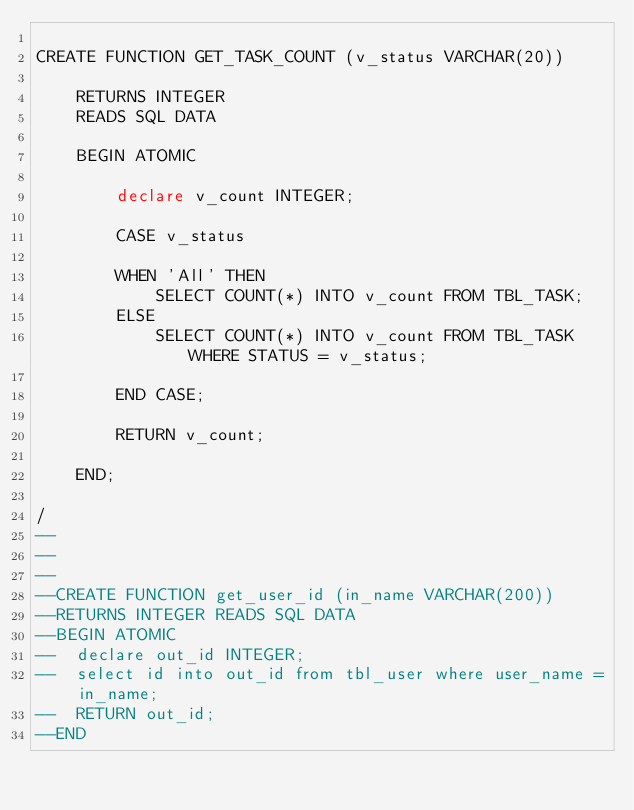Convert code to text. <code><loc_0><loc_0><loc_500><loc_500><_SQL_>
CREATE FUNCTION GET_TASK_COUNT (v_status VARCHAR(20))
	
	RETURNS INTEGER
	READS SQL DATA
	
	BEGIN ATOMIC
	
		declare v_count INTEGER;
		
		CASE v_status
		
		WHEN 'All' THEN
			SELECT COUNT(*) INTO v_count FROM TBL_TASK;
		ELSE
			SELECT COUNT(*) INTO v_count FROM TBL_TASK WHERE STATUS = v_status;
		
		END CASE;
		
		RETURN v_count;
	
	END;
	
/
--
--
--
--CREATE FUNCTION get_user_id (in_name VARCHAR(200))
--RETURNS INTEGER READS SQL DATA 
--BEGIN ATOMIC
--  declare out_id INTEGER;
--  select id into out_id from tbl_user where user_name = in_name;
--  RETURN out_id;
--END
 

</code> 